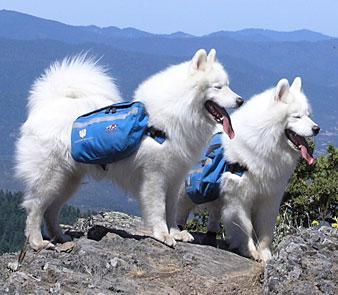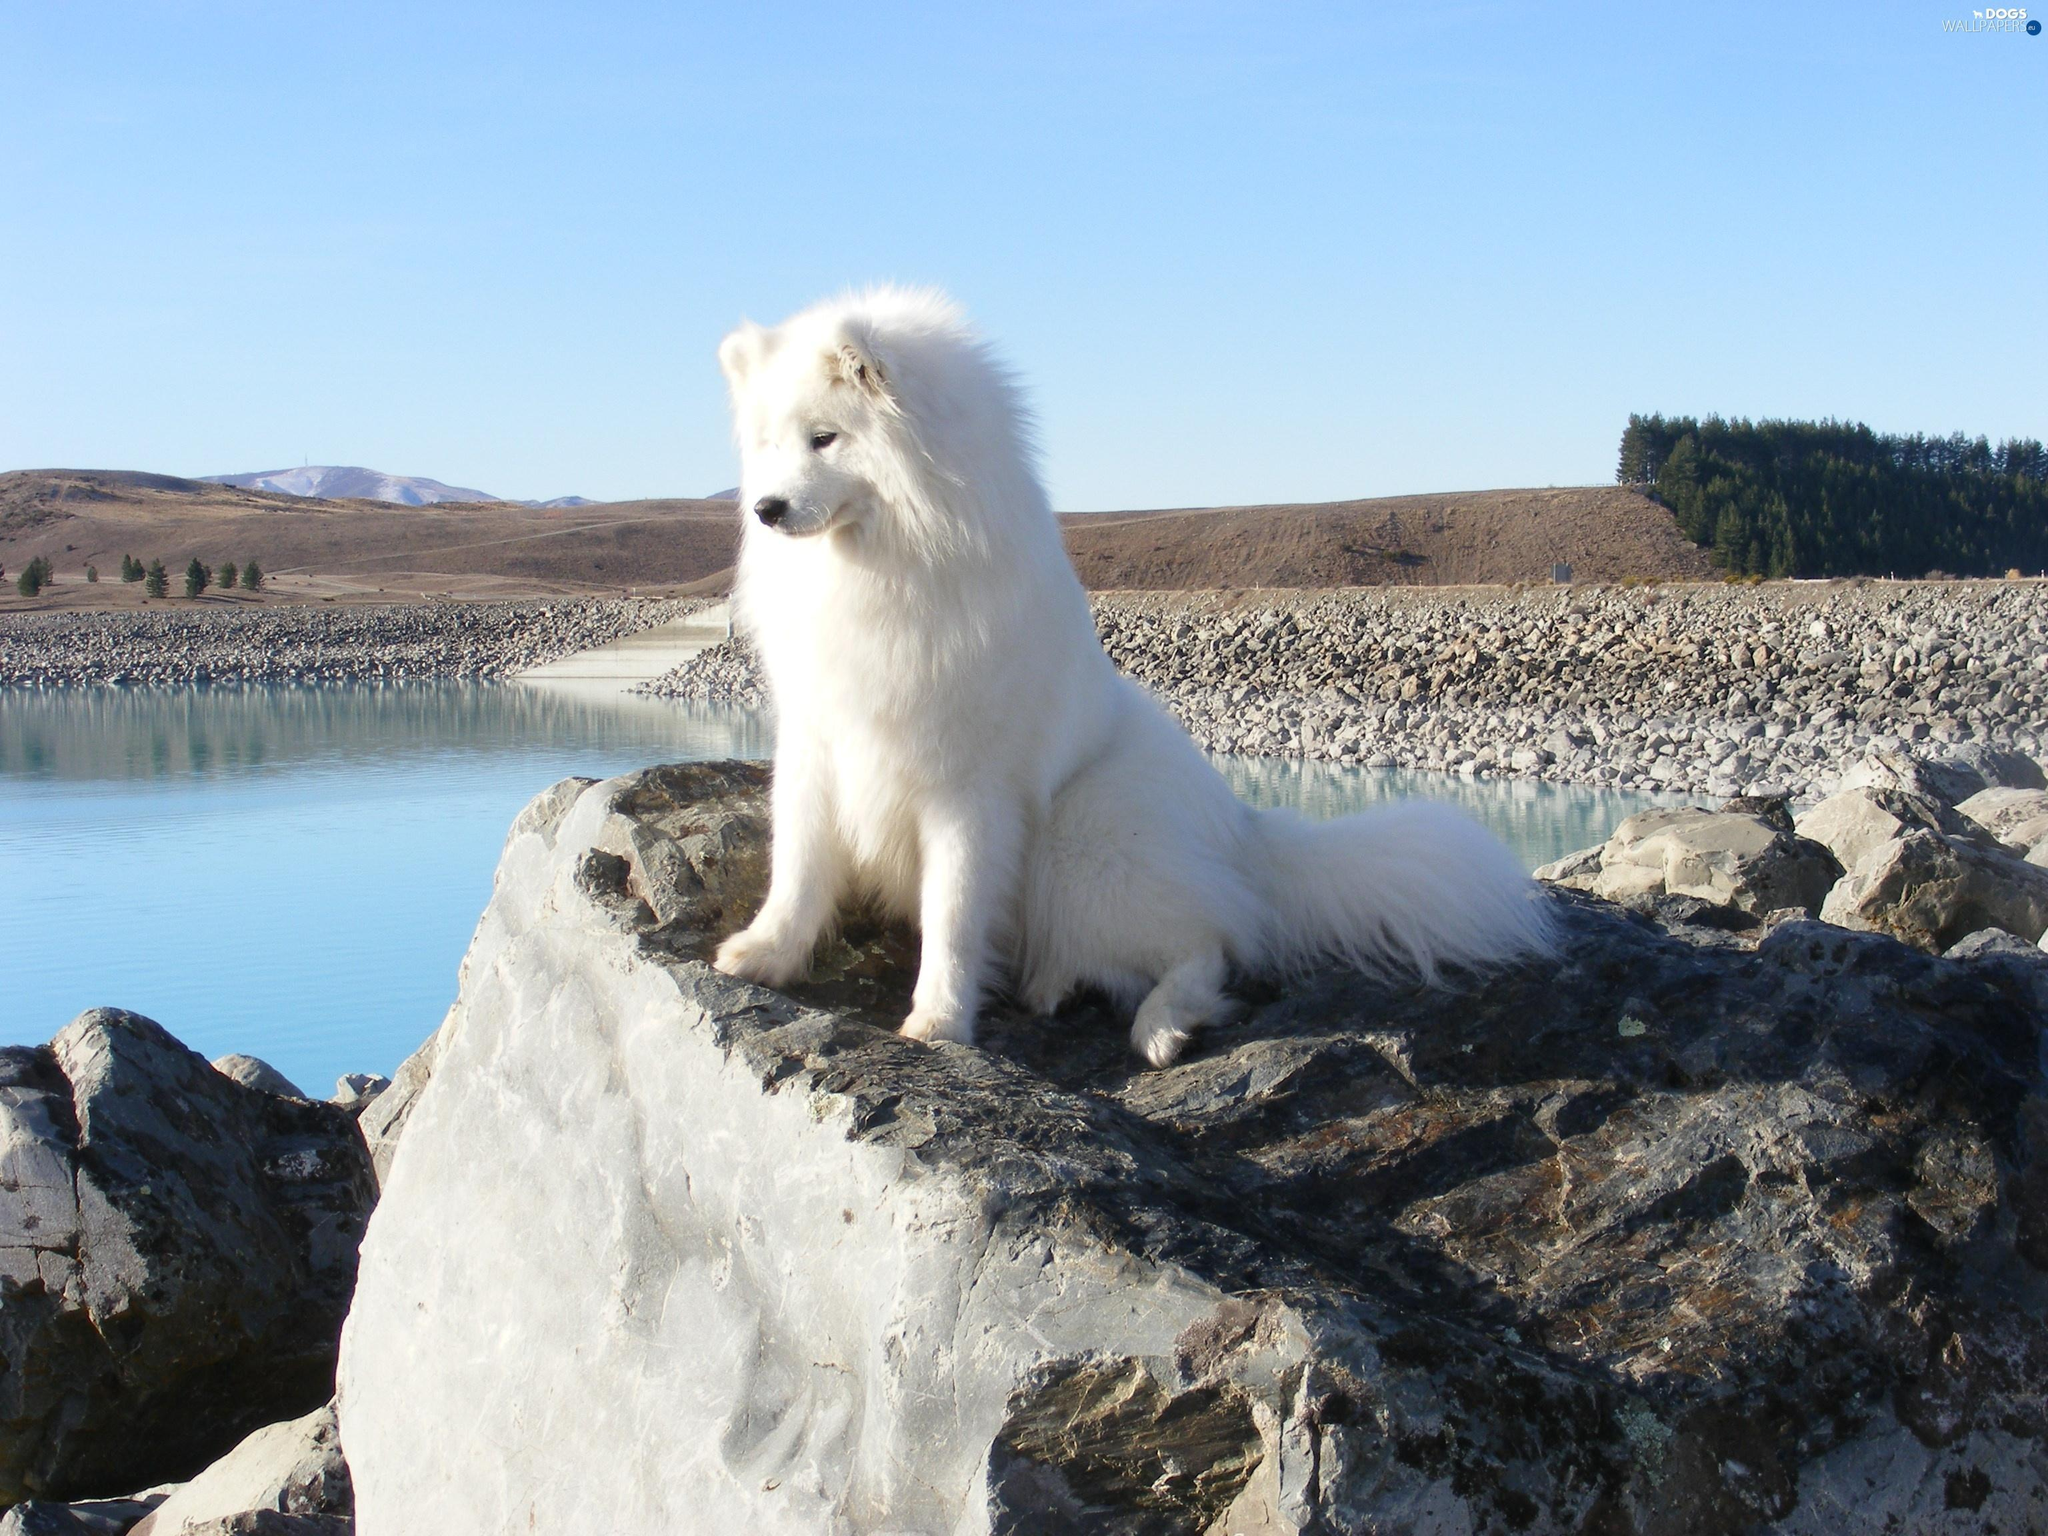The first image is the image on the left, the second image is the image on the right. Considering the images on both sides, is "There are two white dogs with blue packs in one image." valid? Answer yes or no. Yes. The first image is the image on the left, the second image is the image on the right. Analyze the images presented: Is the assertion "there are multiple dogs in blue backpacks" valid? Answer yes or no. Yes. 